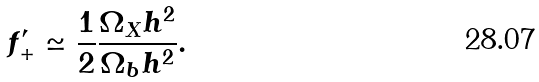<formula> <loc_0><loc_0><loc_500><loc_500>f ^ { \prime } _ { + } \simeq \frac { 1 } { 2 } \frac { \Omega _ { X } h ^ { 2 } } { \Omega _ { b } h ^ { 2 } } .</formula> 